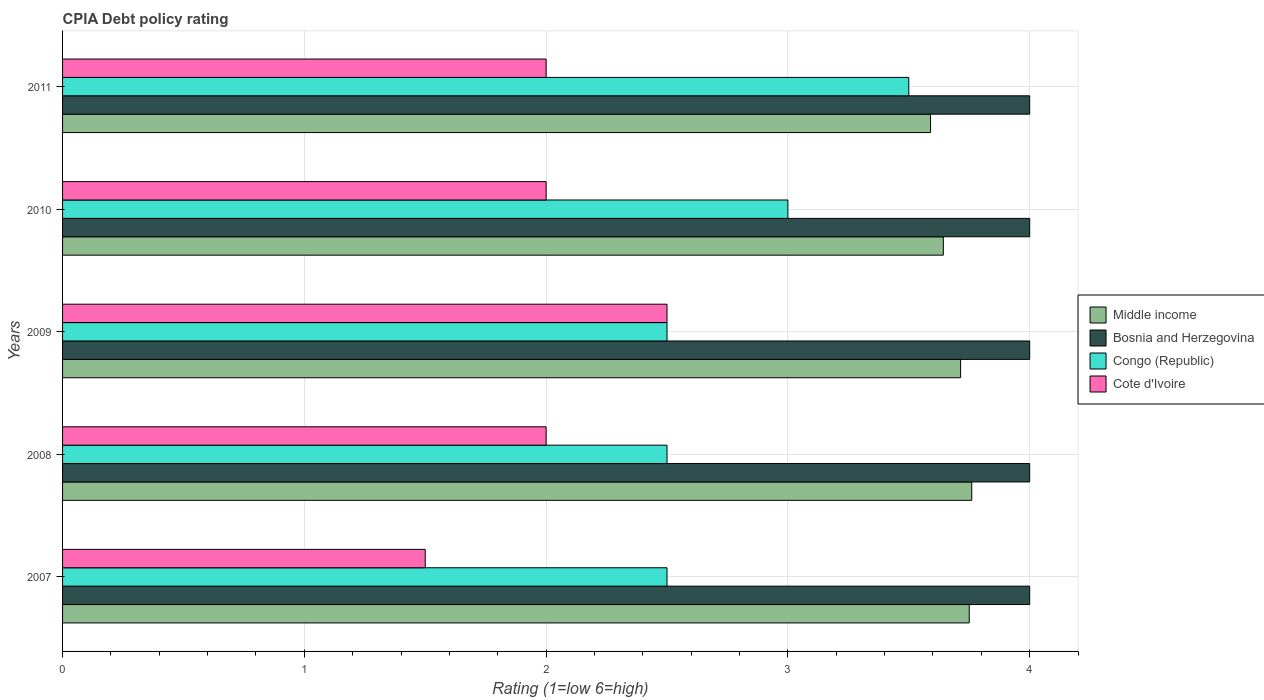Are the number of bars on each tick of the Y-axis equal?
Your answer should be very brief. Yes. How many bars are there on the 3rd tick from the bottom?
Your answer should be compact. 4. What is the label of the 2nd group of bars from the top?
Offer a terse response. 2010. What is the CPIA rating in Middle income in 2007?
Make the answer very short. 3.75. Across all years, what is the maximum CPIA rating in Middle income?
Provide a short and direct response. 3.76. In which year was the CPIA rating in Cote d'Ivoire maximum?
Provide a short and direct response. 2009. In which year was the CPIA rating in Bosnia and Herzegovina minimum?
Offer a very short reply. 2007. What is the difference between the CPIA rating in Cote d'Ivoire in 2007 and that in 2008?
Offer a terse response. -0.5. What is the difference between the CPIA rating in Middle income in 2011 and the CPIA rating in Bosnia and Herzegovina in 2007?
Offer a very short reply. -0.41. In the year 2008, what is the difference between the CPIA rating in Middle income and CPIA rating in Cote d'Ivoire?
Offer a terse response. 1.76. What is the ratio of the CPIA rating in Cote d'Ivoire in 2007 to that in 2009?
Provide a succinct answer. 0.6. Is the difference between the CPIA rating in Middle income in 2007 and 2009 greater than the difference between the CPIA rating in Cote d'Ivoire in 2007 and 2009?
Make the answer very short. Yes. What is the difference between the highest and the second highest CPIA rating in Bosnia and Herzegovina?
Offer a terse response. 0. Is the sum of the CPIA rating in Bosnia and Herzegovina in 2010 and 2011 greater than the maximum CPIA rating in Middle income across all years?
Keep it short and to the point. Yes. What does the 4th bar from the top in 2008 represents?
Provide a succinct answer. Middle income. What does the 3rd bar from the bottom in 2008 represents?
Your answer should be compact. Congo (Republic). How many bars are there?
Your answer should be very brief. 20. Does the graph contain any zero values?
Offer a very short reply. No. How are the legend labels stacked?
Give a very brief answer. Vertical. What is the title of the graph?
Your answer should be compact. CPIA Debt policy rating. Does "Botswana" appear as one of the legend labels in the graph?
Make the answer very short. No. What is the label or title of the X-axis?
Give a very brief answer. Rating (1=low 6=high). What is the label or title of the Y-axis?
Provide a succinct answer. Years. What is the Rating (1=low 6=high) in Middle income in 2007?
Give a very brief answer. 3.75. What is the Rating (1=low 6=high) of Bosnia and Herzegovina in 2007?
Your answer should be compact. 4. What is the Rating (1=low 6=high) in Middle income in 2008?
Offer a terse response. 3.76. What is the Rating (1=low 6=high) in Bosnia and Herzegovina in 2008?
Make the answer very short. 4. What is the Rating (1=low 6=high) in Congo (Republic) in 2008?
Provide a succinct answer. 2.5. What is the Rating (1=low 6=high) in Cote d'Ivoire in 2008?
Your answer should be very brief. 2. What is the Rating (1=low 6=high) in Middle income in 2009?
Your answer should be compact. 3.71. What is the Rating (1=low 6=high) of Congo (Republic) in 2009?
Offer a terse response. 2.5. What is the Rating (1=low 6=high) of Middle income in 2010?
Give a very brief answer. 3.64. What is the Rating (1=low 6=high) of Bosnia and Herzegovina in 2010?
Give a very brief answer. 4. What is the Rating (1=low 6=high) in Cote d'Ivoire in 2010?
Your response must be concise. 2. What is the Rating (1=low 6=high) in Middle income in 2011?
Offer a very short reply. 3.59. What is the Rating (1=low 6=high) in Bosnia and Herzegovina in 2011?
Ensure brevity in your answer.  4. What is the Rating (1=low 6=high) in Congo (Republic) in 2011?
Offer a very short reply. 3.5. What is the Rating (1=low 6=high) of Cote d'Ivoire in 2011?
Give a very brief answer. 2. Across all years, what is the maximum Rating (1=low 6=high) of Middle income?
Keep it short and to the point. 3.76. Across all years, what is the maximum Rating (1=low 6=high) of Cote d'Ivoire?
Offer a very short reply. 2.5. Across all years, what is the minimum Rating (1=low 6=high) of Middle income?
Provide a succinct answer. 3.59. Across all years, what is the minimum Rating (1=low 6=high) of Congo (Republic)?
Ensure brevity in your answer.  2.5. What is the total Rating (1=low 6=high) in Middle income in the graph?
Ensure brevity in your answer.  18.46. What is the total Rating (1=low 6=high) of Bosnia and Herzegovina in the graph?
Your answer should be compact. 20. What is the total Rating (1=low 6=high) in Congo (Republic) in the graph?
Keep it short and to the point. 14. What is the total Rating (1=low 6=high) in Cote d'Ivoire in the graph?
Keep it short and to the point. 10. What is the difference between the Rating (1=low 6=high) in Middle income in 2007 and that in 2008?
Make the answer very short. -0.01. What is the difference between the Rating (1=low 6=high) in Bosnia and Herzegovina in 2007 and that in 2008?
Offer a terse response. 0. What is the difference between the Rating (1=low 6=high) of Congo (Republic) in 2007 and that in 2008?
Your response must be concise. 0. What is the difference between the Rating (1=low 6=high) of Middle income in 2007 and that in 2009?
Your answer should be very brief. 0.04. What is the difference between the Rating (1=low 6=high) in Bosnia and Herzegovina in 2007 and that in 2009?
Your answer should be very brief. 0. What is the difference between the Rating (1=low 6=high) of Middle income in 2007 and that in 2010?
Offer a very short reply. 0.11. What is the difference between the Rating (1=low 6=high) in Bosnia and Herzegovina in 2007 and that in 2010?
Offer a very short reply. 0. What is the difference between the Rating (1=low 6=high) of Cote d'Ivoire in 2007 and that in 2010?
Your response must be concise. -0.5. What is the difference between the Rating (1=low 6=high) in Middle income in 2007 and that in 2011?
Offer a very short reply. 0.16. What is the difference between the Rating (1=low 6=high) of Congo (Republic) in 2007 and that in 2011?
Give a very brief answer. -1. What is the difference between the Rating (1=low 6=high) in Middle income in 2008 and that in 2009?
Your answer should be very brief. 0.05. What is the difference between the Rating (1=low 6=high) of Congo (Republic) in 2008 and that in 2009?
Your answer should be compact. 0. What is the difference between the Rating (1=low 6=high) of Cote d'Ivoire in 2008 and that in 2009?
Your response must be concise. -0.5. What is the difference between the Rating (1=low 6=high) of Middle income in 2008 and that in 2010?
Keep it short and to the point. 0.12. What is the difference between the Rating (1=low 6=high) of Middle income in 2008 and that in 2011?
Your answer should be very brief. 0.17. What is the difference between the Rating (1=low 6=high) in Bosnia and Herzegovina in 2008 and that in 2011?
Provide a succinct answer. 0. What is the difference between the Rating (1=low 6=high) in Congo (Republic) in 2008 and that in 2011?
Keep it short and to the point. -1. What is the difference between the Rating (1=low 6=high) of Cote d'Ivoire in 2008 and that in 2011?
Give a very brief answer. 0. What is the difference between the Rating (1=low 6=high) in Middle income in 2009 and that in 2010?
Give a very brief answer. 0.07. What is the difference between the Rating (1=low 6=high) of Bosnia and Herzegovina in 2009 and that in 2010?
Keep it short and to the point. 0. What is the difference between the Rating (1=low 6=high) of Congo (Republic) in 2009 and that in 2010?
Keep it short and to the point. -0.5. What is the difference between the Rating (1=low 6=high) of Middle income in 2009 and that in 2011?
Your answer should be very brief. 0.12. What is the difference between the Rating (1=low 6=high) in Middle income in 2010 and that in 2011?
Your response must be concise. 0.05. What is the difference between the Rating (1=low 6=high) in Bosnia and Herzegovina in 2007 and the Rating (1=low 6=high) in Congo (Republic) in 2008?
Give a very brief answer. 1.5. What is the difference between the Rating (1=low 6=high) of Middle income in 2007 and the Rating (1=low 6=high) of Bosnia and Herzegovina in 2009?
Your answer should be very brief. -0.25. What is the difference between the Rating (1=low 6=high) in Middle income in 2007 and the Rating (1=low 6=high) in Congo (Republic) in 2009?
Provide a short and direct response. 1.25. What is the difference between the Rating (1=low 6=high) in Bosnia and Herzegovina in 2007 and the Rating (1=low 6=high) in Congo (Republic) in 2009?
Keep it short and to the point. 1.5. What is the difference between the Rating (1=low 6=high) of Bosnia and Herzegovina in 2007 and the Rating (1=low 6=high) of Cote d'Ivoire in 2009?
Give a very brief answer. 1.5. What is the difference between the Rating (1=low 6=high) of Congo (Republic) in 2007 and the Rating (1=low 6=high) of Cote d'Ivoire in 2009?
Your answer should be very brief. 0. What is the difference between the Rating (1=low 6=high) of Middle income in 2007 and the Rating (1=low 6=high) of Bosnia and Herzegovina in 2010?
Provide a short and direct response. -0.25. What is the difference between the Rating (1=low 6=high) in Bosnia and Herzegovina in 2007 and the Rating (1=low 6=high) in Cote d'Ivoire in 2010?
Your response must be concise. 2. What is the difference between the Rating (1=low 6=high) of Congo (Republic) in 2007 and the Rating (1=low 6=high) of Cote d'Ivoire in 2010?
Your response must be concise. 0.5. What is the difference between the Rating (1=low 6=high) of Middle income in 2007 and the Rating (1=low 6=high) of Cote d'Ivoire in 2011?
Your answer should be very brief. 1.75. What is the difference between the Rating (1=low 6=high) of Bosnia and Herzegovina in 2007 and the Rating (1=low 6=high) of Congo (Republic) in 2011?
Your answer should be compact. 0.5. What is the difference between the Rating (1=low 6=high) in Bosnia and Herzegovina in 2007 and the Rating (1=low 6=high) in Cote d'Ivoire in 2011?
Provide a succinct answer. 2. What is the difference between the Rating (1=low 6=high) in Middle income in 2008 and the Rating (1=low 6=high) in Bosnia and Herzegovina in 2009?
Provide a succinct answer. -0.24. What is the difference between the Rating (1=low 6=high) of Middle income in 2008 and the Rating (1=low 6=high) of Congo (Republic) in 2009?
Your answer should be compact. 1.26. What is the difference between the Rating (1=low 6=high) of Middle income in 2008 and the Rating (1=low 6=high) of Cote d'Ivoire in 2009?
Provide a short and direct response. 1.26. What is the difference between the Rating (1=low 6=high) of Bosnia and Herzegovina in 2008 and the Rating (1=low 6=high) of Congo (Republic) in 2009?
Make the answer very short. 1.5. What is the difference between the Rating (1=low 6=high) in Congo (Republic) in 2008 and the Rating (1=low 6=high) in Cote d'Ivoire in 2009?
Make the answer very short. 0. What is the difference between the Rating (1=low 6=high) of Middle income in 2008 and the Rating (1=low 6=high) of Bosnia and Herzegovina in 2010?
Offer a very short reply. -0.24. What is the difference between the Rating (1=low 6=high) of Middle income in 2008 and the Rating (1=low 6=high) of Congo (Republic) in 2010?
Make the answer very short. 0.76. What is the difference between the Rating (1=low 6=high) of Middle income in 2008 and the Rating (1=low 6=high) of Cote d'Ivoire in 2010?
Provide a succinct answer. 1.76. What is the difference between the Rating (1=low 6=high) of Bosnia and Herzegovina in 2008 and the Rating (1=low 6=high) of Cote d'Ivoire in 2010?
Ensure brevity in your answer.  2. What is the difference between the Rating (1=low 6=high) of Middle income in 2008 and the Rating (1=low 6=high) of Bosnia and Herzegovina in 2011?
Make the answer very short. -0.24. What is the difference between the Rating (1=low 6=high) of Middle income in 2008 and the Rating (1=low 6=high) of Congo (Republic) in 2011?
Provide a succinct answer. 0.26. What is the difference between the Rating (1=low 6=high) in Middle income in 2008 and the Rating (1=low 6=high) in Cote d'Ivoire in 2011?
Keep it short and to the point. 1.76. What is the difference between the Rating (1=low 6=high) of Congo (Republic) in 2008 and the Rating (1=low 6=high) of Cote d'Ivoire in 2011?
Give a very brief answer. 0.5. What is the difference between the Rating (1=low 6=high) in Middle income in 2009 and the Rating (1=low 6=high) in Bosnia and Herzegovina in 2010?
Your answer should be compact. -0.29. What is the difference between the Rating (1=low 6=high) of Middle income in 2009 and the Rating (1=low 6=high) of Cote d'Ivoire in 2010?
Provide a succinct answer. 1.71. What is the difference between the Rating (1=low 6=high) in Bosnia and Herzegovina in 2009 and the Rating (1=low 6=high) in Cote d'Ivoire in 2010?
Keep it short and to the point. 2. What is the difference between the Rating (1=low 6=high) in Congo (Republic) in 2009 and the Rating (1=low 6=high) in Cote d'Ivoire in 2010?
Provide a succinct answer. 0.5. What is the difference between the Rating (1=low 6=high) of Middle income in 2009 and the Rating (1=low 6=high) of Bosnia and Herzegovina in 2011?
Ensure brevity in your answer.  -0.29. What is the difference between the Rating (1=low 6=high) of Middle income in 2009 and the Rating (1=low 6=high) of Congo (Republic) in 2011?
Keep it short and to the point. 0.21. What is the difference between the Rating (1=low 6=high) in Middle income in 2009 and the Rating (1=low 6=high) in Cote d'Ivoire in 2011?
Make the answer very short. 1.71. What is the difference between the Rating (1=low 6=high) in Bosnia and Herzegovina in 2009 and the Rating (1=low 6=high) in Congo (Republic) in 2011?
Keep it short and to the point. 0.5. What is the difference between the Rating (1=low 6=high) of Bosnia and Herzegovina in 2009 and the Rating (1=low 6=high) of Cote d'Ivoire in 2011?
Make the answer very short. 2. What is the difference between the Rating (1=low 6=high) in Middle income in 2010 and the Rating (1=low 6=high) in Bosnia and Herzegovina in 2011?
Provide a succinct answer. -0.36. What is the difference between the Rating (1=low 6=high) of Middle income in 2010 and the Rating (1=low 6=high) of Congo (Republic) in 2011?
Provide a short and direct response. 0.14. What is the difference between the Rating (1=low 6=high) in Middle income in 2010 and the Rating (1=low 6=high) in Cote d'Ivoire in 2011?
Your answer should be very brief. 1.64. What is the difference between the Rating (1=low 6=high) in Bosnia and Herzegovina in 2010 and the Rating (1=low 6=high) in Congo (Republic) in 2011?
Keep it short and to the point. 0.5. What is the difference between the Rating (1=low 6=high) of Congo (Republic) in 2010 and the Rating (1=low 6=high) of Cote d'Ivoire in 2011?
Provide a succinct answer. 1. What is the average Rating (1=low 6=high) of Middle income per year?
Your answer should be very brief. 3.69. What is the average Rating (1=low 6=high) in Congo (Republic) per year?
Ensure brevity in your answer.  2.8. What is the average Rating (1=low 6=high) in Cote d'Ivoire per year?
Provide a short and direct response. 2. In the year 2007, what is the difference between the Rating (1=low 6=high) of Middle income and Rating (1=low 6=high) of Cote d'Ivoire?
Offer a terse response. 2.25. In the year 2007, what is the difference between the Rating (1=low 6=high) in Bosnia and Herzegovina and Rating (1=low 6=high) in Congo (Republic)?
Offer a terse response. 1.5. In the year 2007, what is the difference between the Rating (1=low 6=high) in Bosnia and Herzegovina and Rating (1=low 6=high) in Cote d'Ivoire?
Your answer should be very brief. 2.5. In the year 2008, what is the difference between the Rating (1=low 6=high) of Middle income and Rating (1=low 6=high) of Bosnia and Herzegovina?
Give a very brief answer. -0.24. In the year 2008, what is the difference between the Rating (1=low 6=high) of Middle income and Rating (1=low 6=high) of Congo (Republic)?
Provide a succinct answer. 1.26. In the year 2008, what is the difference between the Rating (1=low 6=high) in Middle income and Rating (1=low 6=high) in Cote d'Ivoire?
Provide a succinct answer. 1.76. In the year 2008, what is the difference between the Rating (1=low 6=high) of Congo (Republic) and Rating (1=low 6=high) of Cote d'Ivoire?
Your answer should be compact. 0.5. In the year 2009, what is the difference between the Rating (1=low 6=high) of Middle income and Rating (1=low 6=high) of Bosnia and Herzegovina?
Provide a short and direct response. -0.29. In the year 2009, what is the difference between the Rating (1=low 6=high) in Middle income and Rating (1=low 6=high) in Congo (Republic)?
Ensure brevity in your answer.  1.21. In the year 2009, what is the difference between the Rating (1=low 6=high) of Middle income and Rating (1=low 6=high) of Cote d'Ivoire?
Provide a succinct answer. 1.21. In the year 2009, what is the difference between the Rating (1=low 6=high) of Congo (Republic) and Rating (1=low 6=high) of Cote d'Ivoire?
Your answer should be very brief. 0. In the year 2010, what is the difference between the Rating (1=low 6=high) of Middle income and Rating (1=low 6=high) of Bosnia and Herzegovina?
Make the answer very short. -0.36. In the year 2010, what is the difference between the Rating (1=low 6=high) in Middle income and Rating (1=low 6=high) in Congo (Republic)?
Keep it short and to the point. 0.64. In the year 2010, what is the difference between the Rating (1=low 6=high) in Middle income and Rating (1=low 6=high) in Cote d'Ivoire?
Offer a very short reply. 1.64. In the year 2010, what is the difference between the Rating (1=low 6=high) in Bosnia and Herzegovina and Rating (1=low 6=high) in Cote d'Ivoire?
Keep it short and to the point. 2. In the year 2010, what is the difference between the Rating (1=low 6=high) of Congo (Republic) and Rating (1=low 6=high) of Cote d'Ivoire?
Keep it short and to the point. 1. In the year 2011, what is the difference between the Rating (1=low 6=high) in Middle income and Rating (1=low 6=high) in Bosnia and Herzegovina?
Give a very brief answer. -0.41. In the year 2011, what is the difference between the Rating (1=low 6=high) of Middle income and Rating (1=low 6=high) of Congo (Republic)?
Offer a terse response. 0.09. In the year 2011, what is the difference between the Rating (1=low 6=high) in Middle income and Rating (1=low 6=high) in Cote d'Ivoire?
Your response must be concise. 1.59. What is the ratio of the Rating (1=low 6=high) in Bosnia and Herzegovina in 2007 to that in 2008?
Ensure brevity in your answer.  1. What is the ratio of the Rating (1=low 6=high) of Cote d'Ivoire in 2007 to that in 2008?
Make the answer very short. 0.75. What is the ratio of the Rating (1=low 6=high) in Middle income in 2007 to that in 2009?
Ensure brevity in your answer.  1.01. What is the ratio of the Rating (1=low 6=high) of Cote d'Ivoire in 2007 to that in 2009?
Your response must be concise. 0.6. What is the ratio of the Rating (1=low 6=high) of Middle income in 2007 to that in 2010?
Offer a very short reply. 1.03. What is the ratio of the Rating (1=low 6=high) of Bosnia and Herzegovina in 2007 to that in 2010?
Give a very brief answer. 1. What is the ratio of the Rating (1=low 6=high) in Cote d'Ivoire in 2007 to that in 2010?
Give a very brief answer. 0.75. What is the ratio of the Rating (1=low 6=high) of Middle income in 2007 to that in 2011?
Provide a short and direct response. 1.04. What is the ratio of the Rating (1=low 6=high) in Bosnia and Herzegovina in 2007 to that in 2011?
Your answer should be compact. 1. What is the ratio of the Rating (1=low 6=high) in Cote d'Ivoire in 2007 to that in 2011?
Give a very brief answer. 0.75. What is the ratio of the Rating (1=low 6=high) of Middle income in 2008 to that in 2009?
Offer a very short reply. 1.01. What is the ratio of the Rating (1=low 6=high) of Congo (Republic) in 2008 to that in 2009?
Ensure brevity in your answer.  1. What is the ratio of the Rating (1=low 6=high) of Cote d'Ivoire in 2008 to that in 2009?
Your answer should be very brief. 0.8. What is the ratio of the Rating (1=low 6=high) of Middle income in 2008 to that in 2010?
Offer a terse response. 1.03. What is the ratio of the Rating (1=low 6=high) in Congo (Republic) in 2008 to that in 2010?
Offer a very short reply. 0.83. What is the ratio of the Rating (1=low 6=high) in Middle income in 2008 to that in 2011?
Provide a short and direct response. 1.05. What is the ratio of the Rating (1=low 6=high) of Cote d'Ivoire in 2008 to that in 2011?
Ensure brevity in your answer.  1. What is the ratio of the Rating (1=low 6=high) in Middle income in 2009 to that in 2010?
Provide a succinct answer. 1.02. What is the ratio of the Rating (1=low 6=high) in Bosnia and Herzegovina in 2009 to that in 2010?
Keep it short and to the point. 1. What is the ratio of the Rating (1=low 6=high) in Congo (Republic) in 2009 to that in 2010?
Offer a very short reply. 0.83. What is the ratio of the Rating (1=low 6=high) in Cote d'Ivoire in 2009 to that in 2010?
Provide a succinct answer. 1.25. What is the ratio of the Rating (1=low 6=high) of Middle income in 2009 to that in 2011?
Keep it short and to the point. 1.03. What is the ratio of the Rating (1=low 6=high) in Middle income in 2010 to that in 2011?
Keep it short and to the point. 1.01. What is the ratio of the Rating (1=low 6=high) in Bosnia and Herzegovina in 2010 to that in 2011?
Offer a terse response. 1. What is the ratio of the Rating (1=low 6=high) of Congo (Republic) in 2010 to that in 2011?
Your response must be concise. 0.86. What is the ratio of the Rating (1=low 6=high) in Cote d'Ivoire in 2010 to that in 2011?
Ensure brevity in your answer.  1. What is the difference between the highest and the second highest Rating (1=low 6=high) of Middle income?
Ensure brevity in your answer.  0.01. What is the difference between the highest and the second highest Rating (1=low 6=high) in Congo (Republic)?
Your response must be concise. 0.5. What is the difference between the highest and the second highest Rating (1=low 6=high) of Cote d'Ivoire?
Your response must be concise. 0.5. What is the difference between the highest and the lowest Rating (1=low 6=high) in Middle income?
Provide a short and direct response. 0.17. What is the difference between the highest and the lowest Rating (1=low 6=high) in Congo (Republic)?
Your response must be concise. 1. 